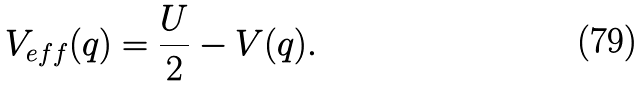Convert formula to latex. <formula><loc_0><loc_0><loc_500><loc_500>V _ { e f f } ( { q } ) = \frac { U } { 2 } - V ( { q } ) .</formula> 